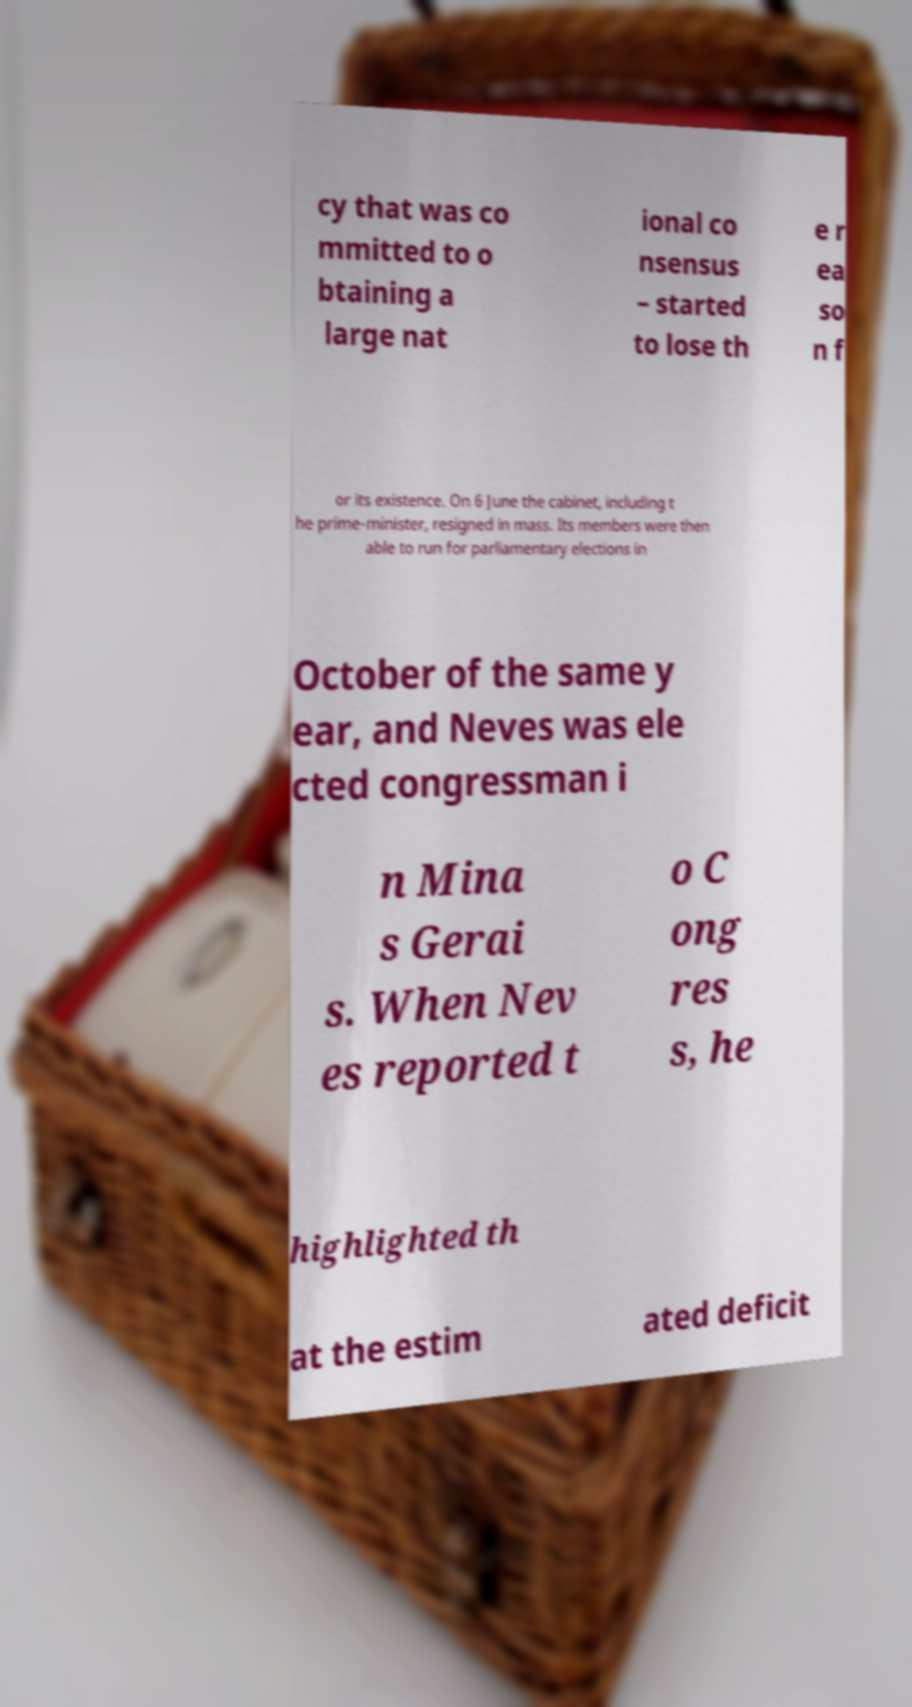Could you assist in decoding the text presented in this image and type it out clearly? cy that was co mmitted to o btaining a large nat ional co nsensus – started to lose th e r ea so n f or its existence. On 6 June the cabinet, including t he prime-minister, resigned in mass. Its members were then able to run for parliamentary elections in October of the same y ear, and Neves was ele cted congressman i n Mina s Gerai s. When Nev es reported t o C ong res s, he highlighted th at the estim ated deficit 